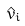Convert formula to latex. <formula><loc_0><loc_0><loc_500><loc_500>\hat { v } _ { i }</formula> 